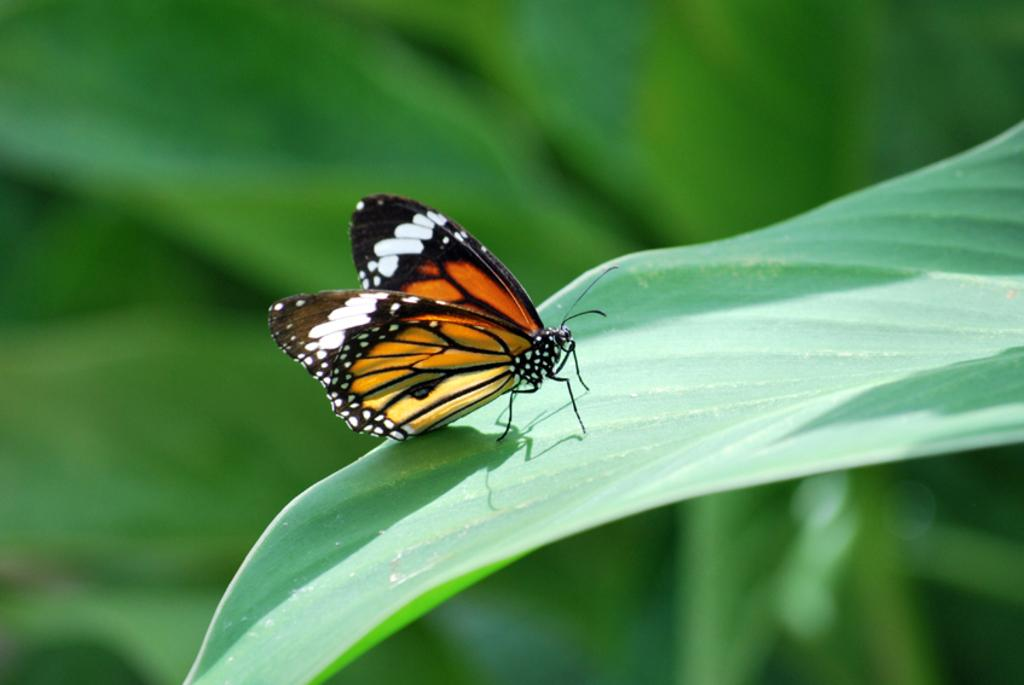What is the main subject of the image? There is a butterfly in the image. Where is the butterfly located? The butterfly is on a leaf. Can you describe the background of the image? The background of the image is blurred. What type of zinc is the lawyer using on the farm in the image? There is no zinc, lawyer, or farm present in the image; it features a butterfly on a leaf with a blurred background. 